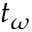<formula> <loc_0><loc_0><loc_500><loc_500>t _ { \omega }</formula> 